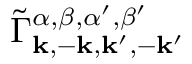<formula> <loc_0><loc_0><loc_500><loc_500>\tilde { \Gamma } _ { k , - k , k ^ { \prime } , - k ^ { \prime } } ^ { \alpha , \beta , \alpha ^ { \prime } , \beta ^ { \prime } }</formula> 